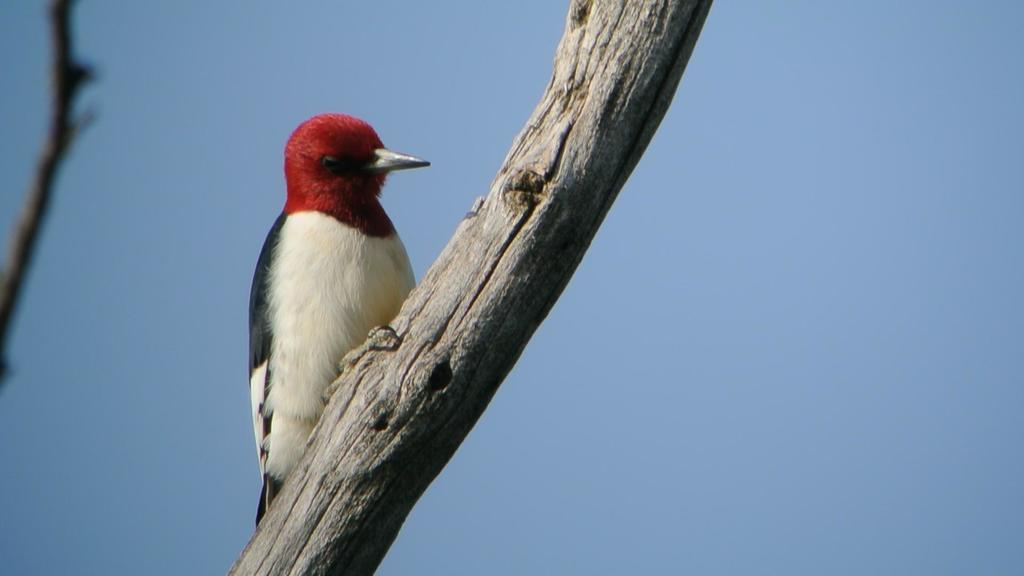What type of animal is in the image? There is a bird in the image. What colors can be seen on the bird? The bird has black, white, and red colors. Where is the bird located in the image? The bird is on a trunk. What color is the sky in the background of the image? The sky in the background is blue. Are the bird's friends angry at the school in the image? There is no mention of friends, anger, or school in the image, so we cannot answer this question. 